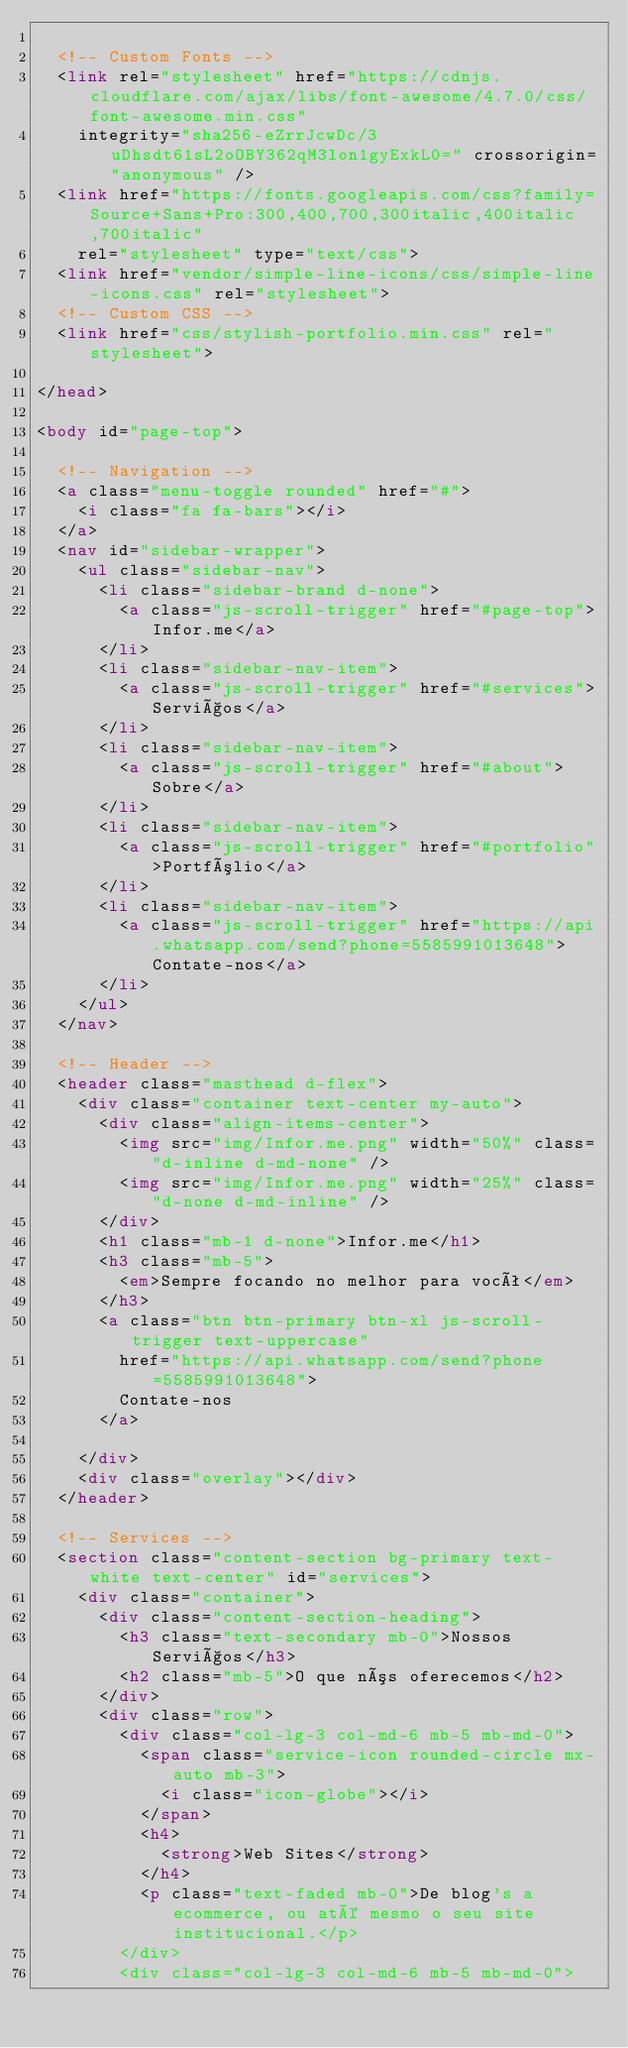Convert code to text. <code><loc_0><loc_0><loc_500><loc_500><_HTML_>
  <!-- Custom Fonts -->
  <link rel="stylesheet" href="https://cdnjs.cloudflare.com/ajax/libs/font-awesome/4.7.0/css/font-awesome.min.css"
    integrity="sha256-eZrrJcwDc/3uDhsdt61sL2oOBY362qM3lon1gyExkL0=" crossorigin="anonymous" />
  <link href="https://fonts.googleapis.com/css?family=Source+Sans+Pro:300,400,700,300italic,400italic,700italic"
    rel="stylesheet" type="text/css">
  <link href="vendor/simple-line-icons/css/simple-line-icons.css" rel="stylesheet">
  <!-- Custom CSS -->
  <link href="css/stylish-portfolio.min.css" rel="stylesheet">

</head>

<body id="page-top">

  <!-- Navigation -->
  <a class="menu-toggle rounded" href="#">
    <i class="fa fa-bars"></i>
  </a>
  <nav id="sidebar-wrapper">
    <ul class="sidebar-nav">
      <li class="sidebar-brand d-none">
        <a class="js-scroll-trigger" href="#page-top">Infor.me</a>
      </li>
      <li class="sidebar-nav-item">
        <a class="js-scroll-trigger" href="#services">Serviços</a>
      </li>
      <li class="sidebar-nav-item">
        <a class="js-scroll-trigger" href="#about">Sobre</a>
      </li>
      <li class="sidebar-nav-item">
        <a class="js-scroll-trigger" href="#portfolio">Portfólio</a>
      </li>
      <li class="sidebar-nav-item">
        <a class="js-scroll-trigger" href="https://api.whatsapp.com/send?phone=5585991013648">Contate-nos</a>
      </li>
    </ul>
  </nav>

  <!-- Header -->
  <header class="masthead d-flex">
    <div class="container text-center my-auto">
      <div class="align-items-center">
        <img src="img/Infor.me.png" width="50%" class="d-inline d-md-none" />
        <img src="img/Infor.me.png" width="25%" class="d-none d-md-inline" />
      </div>
      <h1 class="mb-1 d-none">Infor.me</h1>
      <h3 class="mb-5">
        <em>Sempre focando no melhor para você</em>
      </h3>
      <a class="btn btn-primary btn-xl js-scroll-trigger text-uppercase"
        href="https://api.whatsapp.com/send?phone=5585991013648">
        Contate-nos
      </a>

    </div>
    <div class="overlay"></div>
  </header>

  <!-- Services -->
  <section class="content-section bg-primary text-white text-center" id="services">
    <div class="container">
      <div class="content-section-heading">
        <h3 class="text-secondary mb-0">Nossos Serviços</h3>
        <h2 class="mb-5">O que nós oferecemos</h2>
      </div>
      <div class="row">
        <div class="col-lg-3 col-md-6 mb-5 mb-md-0">
          <span class="service-icon rounded-circle mx-auto mb-3">
            <i class="icon-globe"></i>
          </span>
          <h4>
            <strong>Web Sites</strong>
          </h4>
          <p class="text-faded mb-0">De blog's a ecommerce, ou até mesmo o seu site institucional.</p>
        </div>
        <div class="col-lg-3 col-md-6 mb-5 mb-md-0"></code> 